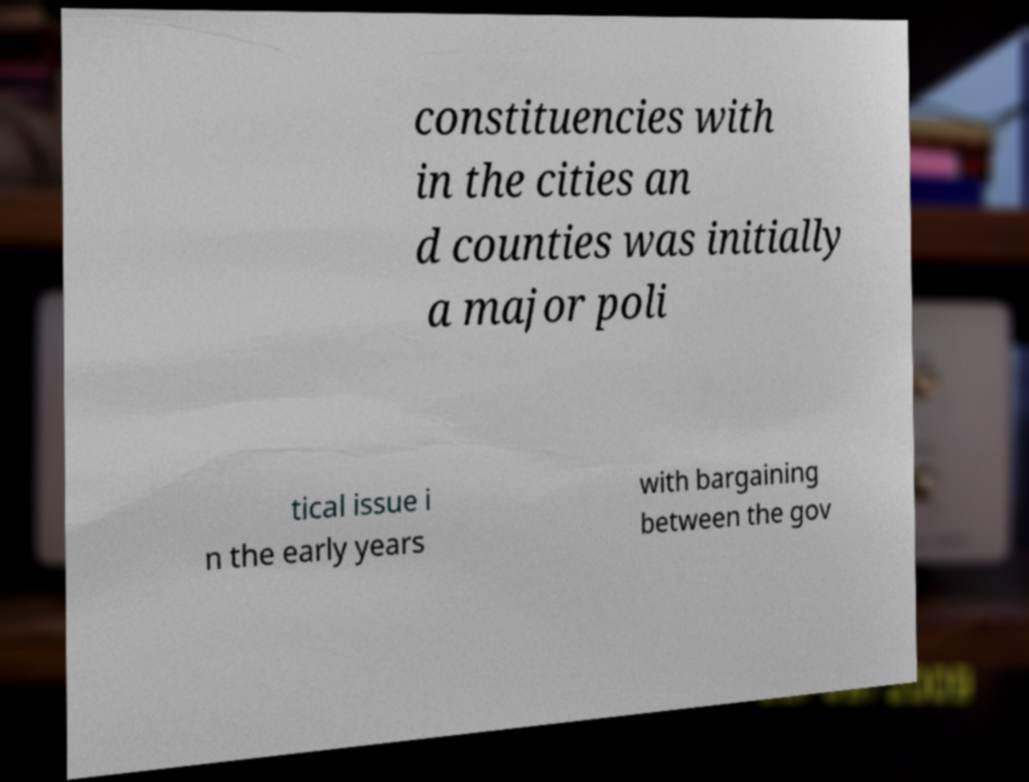For documentation purposes, I need the text within this image transcribed. Could you provide that? constituencies with in the cities an d counties was initially a major poli tical issue i n the early years with bargaining between the gov 